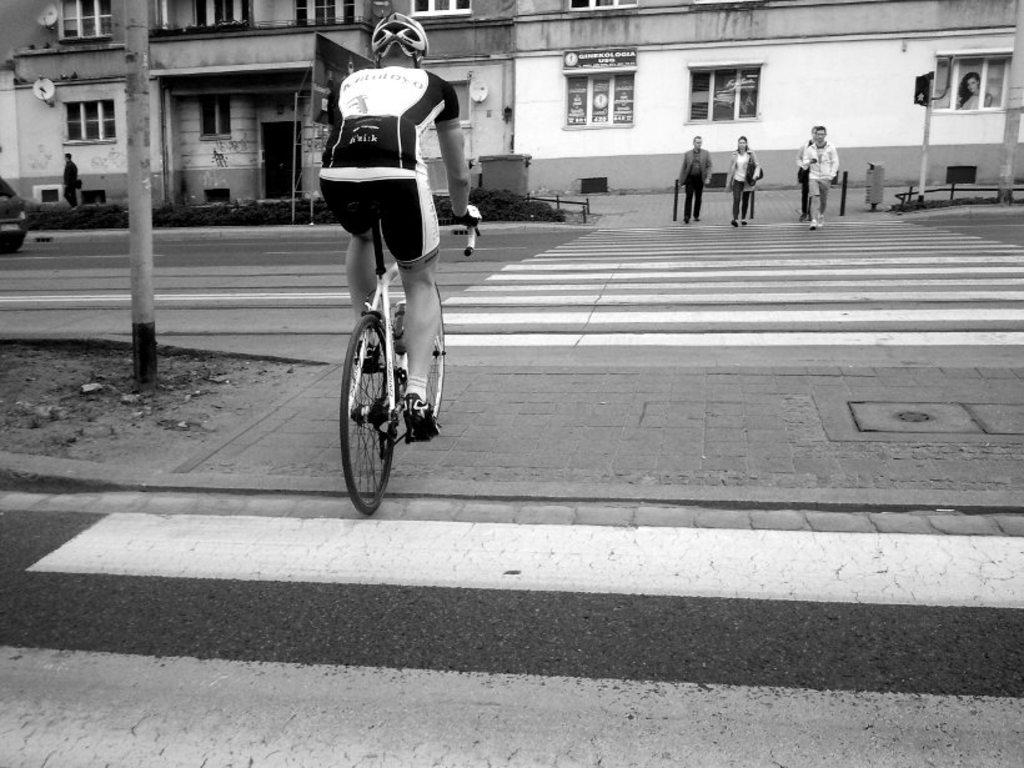What is the man in the image doing? The man is riding a bicycle on the road. What can be seen in the background of the image? There are buildings, a pole, a vehicle, plants, windows, and people crossing the road in the background. Can you describe the setting of the image? The image shows a man riding a bicycle on a road with various background elements, including buildings, a pole, a vehicle, plants, windows, and people crossing the road. What type of station can be seen in the image? There is no station present in the image. 